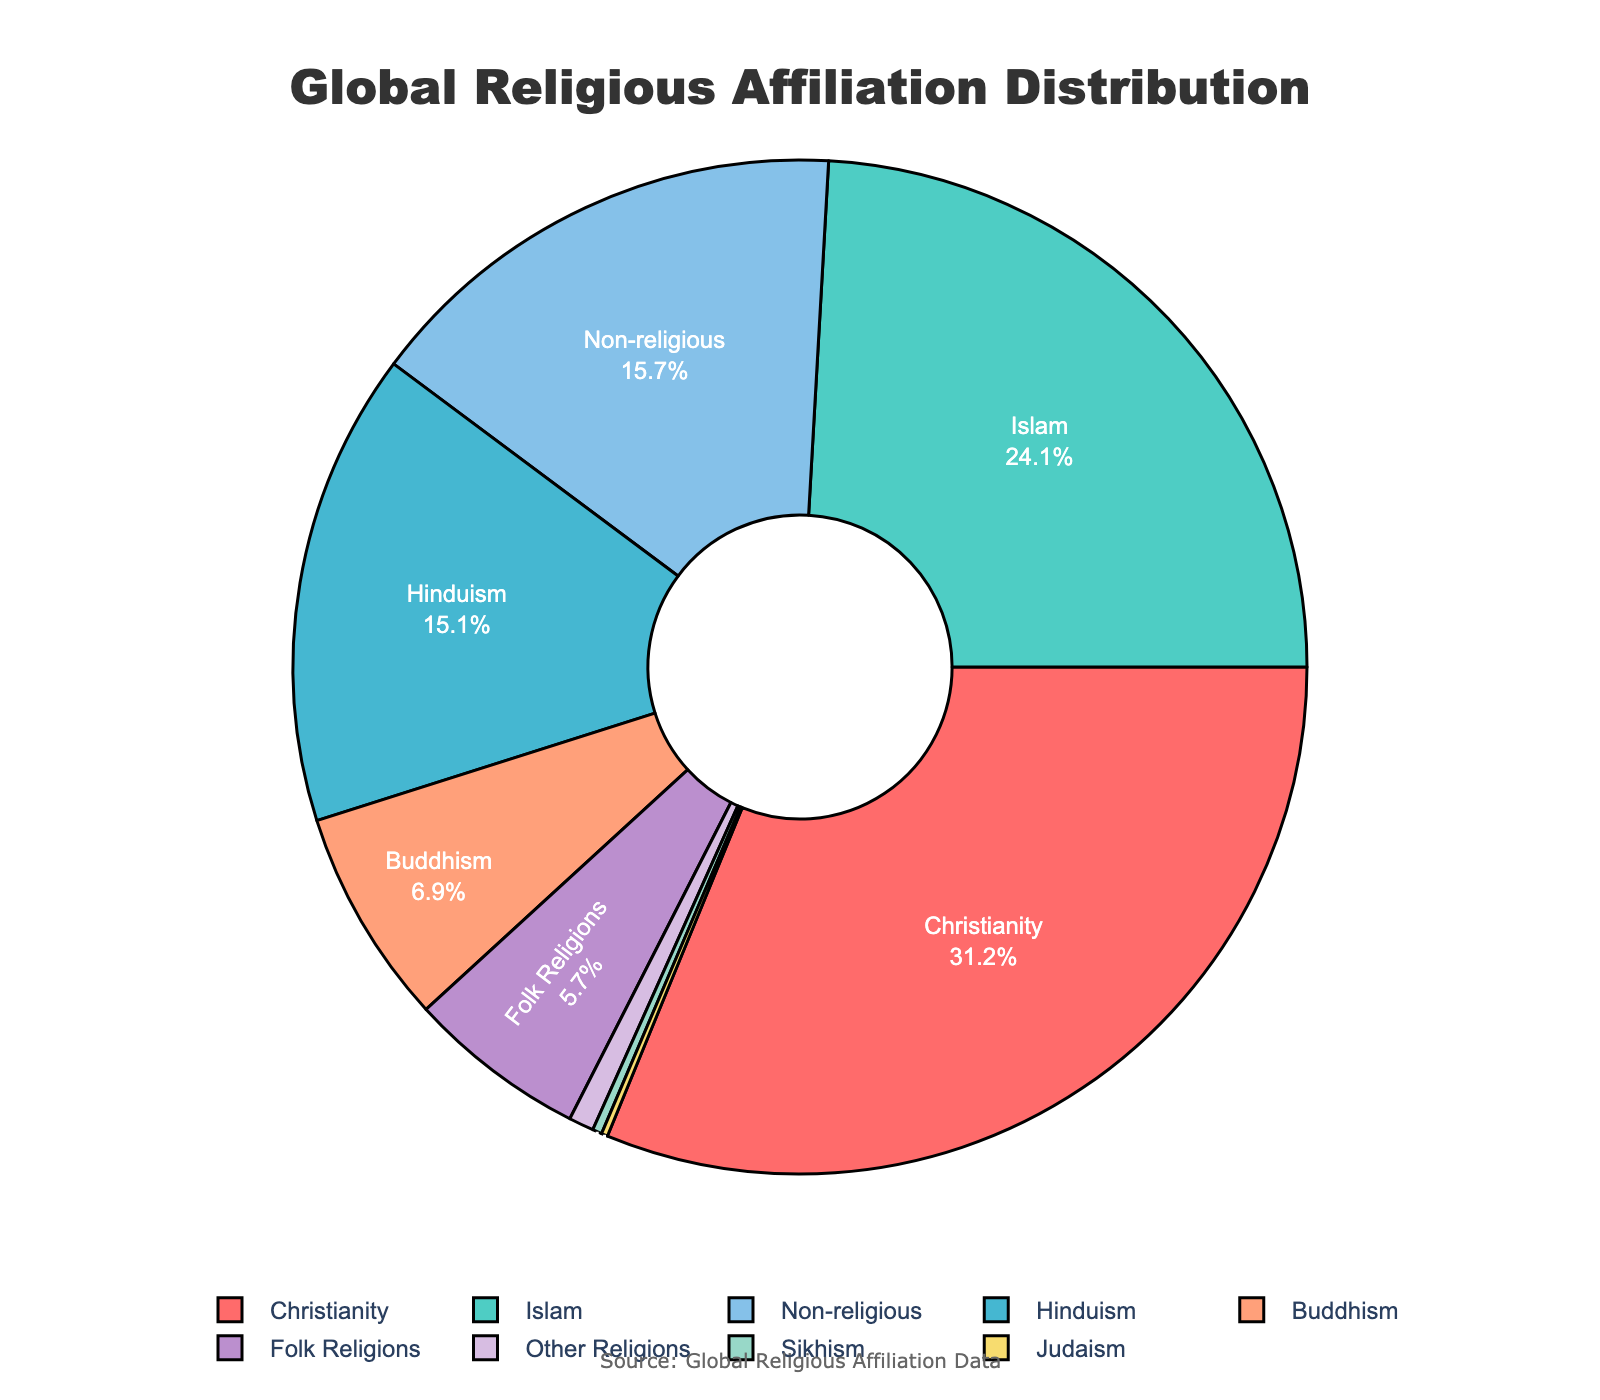What religion has the highest percentage of global affiliation? The figure shows the distribution of global religious affiliation using a pie chart, and the largest segment represents Christianity. By looking at the values given, Christianity has the highest percentage at 31.2%.
Answer: Christianity How does the percentage of Non-religious compare to Hinduism? The pie chart shows Non-religious with 15.7% and Hinduism with 15.1%. Comparing these two, Non-religious has a slightly higher percentage.
Answer: Non-religious is higher What is the sum of percentages for Islam and Buddhism? According to the pie chart, the percentage for Islam is 24.1% and for Buddhism is 6.9%. Adding these two, you get 24.1% + 6.9% = 31%.
Answer: 31% Which religious groups combined make up more than 50% of the world's population? To find this, you need to sum the largest percentages until they exceed 50%. Christianity (31.2%) and Islam (24.1%) together make 31.2% + 24.1% = 55.3%, which is greater than 50%.
Answer: Christianity and Islam What color is used to represent Non-religious in the pie chart? The pie chart uses different colors for each segment. By referring to the provided sequence of colors and segments, Non-religious appears light blue.
Answer: Light blue Is the percentage of Sikhism higher or lower than that of Judaism? The pie chart allocates 0.3% to Sikhism and 0.2% to Judaism. Comparing these, Sikhism has a higher percentage than Judaism.
Answer: Sikhism is higher Which religious group has the smallest percentage? The pie chart shows that Judaism has the smallest segment, with only 0.2% of affiliation.
Answer: Judaism What is the combined percentage of Folk Religions and Other Religions? By adding the percentages from the pie chart: Folk Religions (5.7%) and Other Religions (0.8%), you get 5.7% + 0.8% = 6.5%.
Answer: 6.5% Which has a larger percentage, Buddhism or Non-religious? Referring to the pie chart, Buddhism is 6.9% and Non-religious is 15.7%. The Non-religious group has a larger percentage than Buddhism.
Answer: Non-religious What is the percentage difference between Christianity and Islam? From the pie chart, Christianity is 31.2% and Islam is 24.1%. The difference is 31.2% - 24.1% = 7.1%.
Answer: 7.1% 